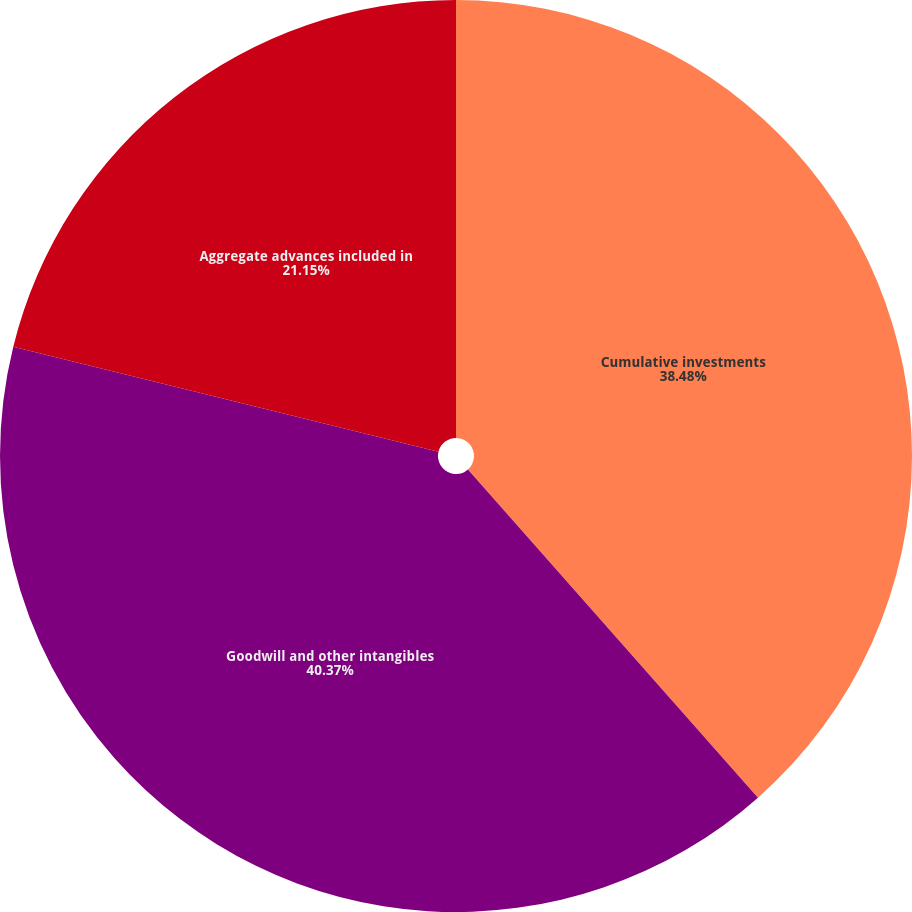Convert chart. <chart><loc_0><loc_0><loc_500><loc_500><pie_chart><fcel>Cumulative investments<fcel>Goodwill and other intangibles<fcel>Aggregate advances included in<nl><fcel>38.48%<fcel>40.37%<fcel>21.15%<nl></chart> 